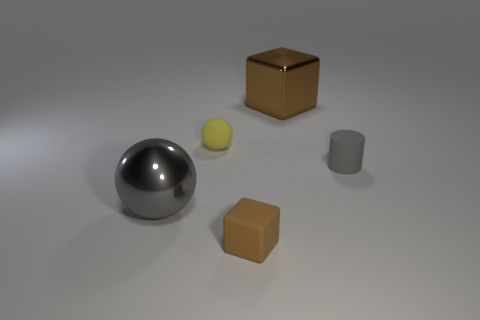There is a brown object that is on the right side of the brown thing that is left of the big object that is on the right side of the big gray object; what is its shape? The brown object you're referring to, which is situated to the right of another brown object and to the left of a larger, metallic sphere, has a cube-like shape consisting of six square faces. 